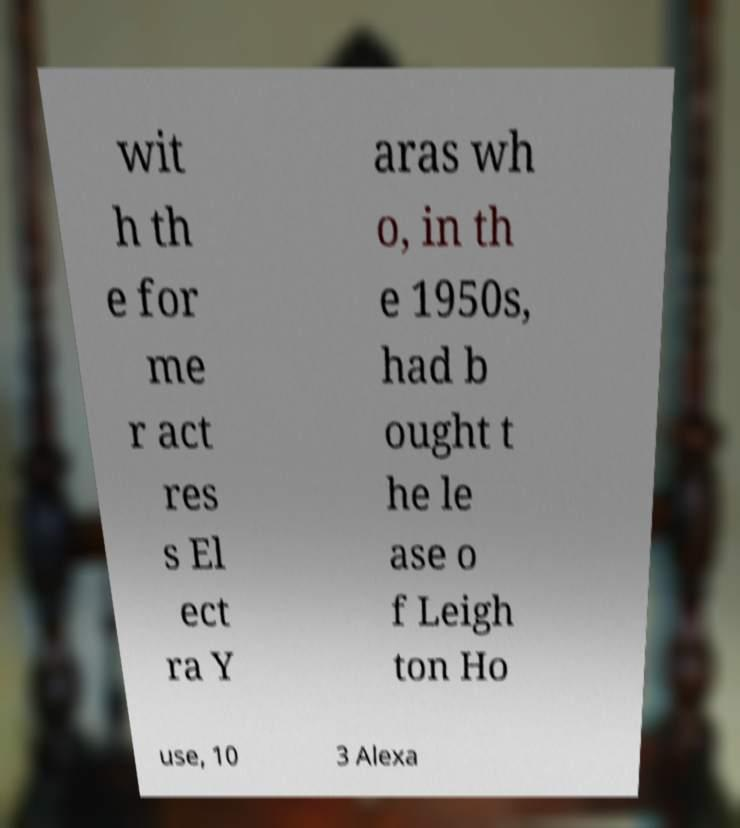There's text embedded in this image that I need extracted. Can you transcribe it verbatim? wit h th e for me r act res s El ect ra Y aras wh o, in th e 1950s, had b ought t he le ase o f Leigh ton Ho use, 10 3 Alexa 